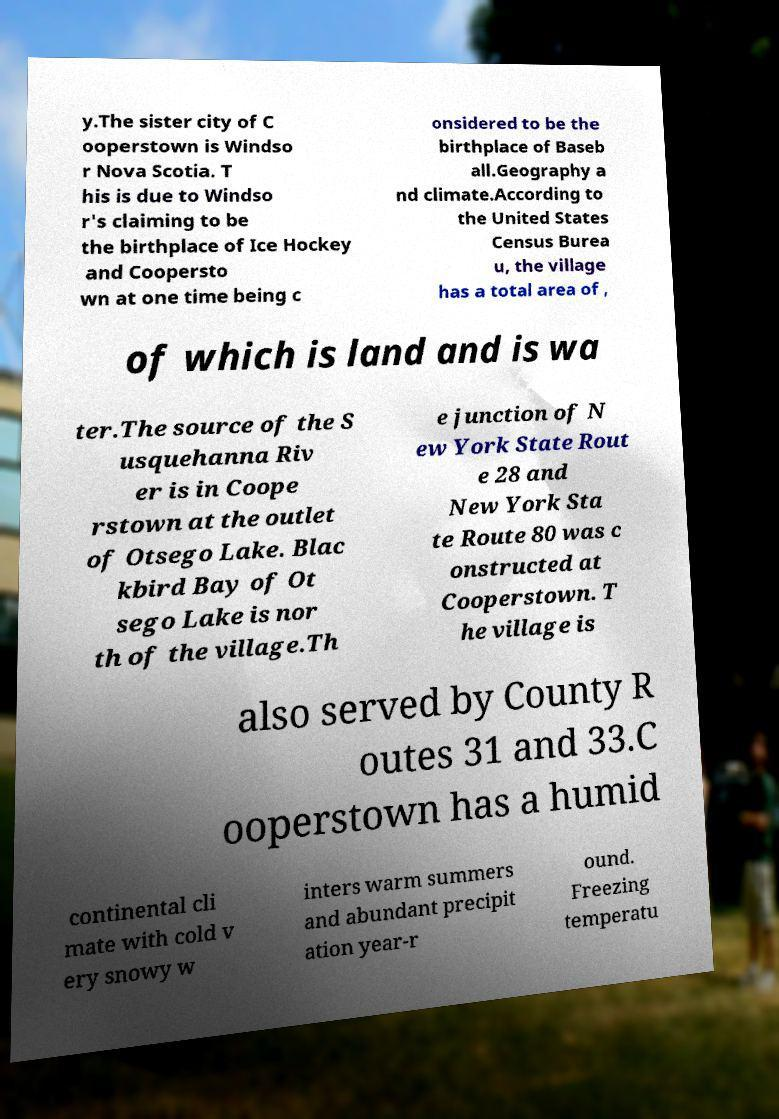For documentation purposes, I need the text within this image transcribed. Could you provide that? y.The sister city of C ooperstown is Windso r Nova Scotia. T his is due to Windso r's claiming to be the birthplace of Ice Hockey and Coopersto wn at one time being c onsidered to be the birthplace of Baseb all.Geography a nd climate.According to the United States Census Burea u, the village has a total area of , of which is land and is wa ter.The source of the S usquehanna Riv er is in Coope rstown at the outlet of Otsego Lake. Blac kbird Bay of Ot sego Lake is nor th of the village.Th e junction of N ew York State Rout e 28 and New York Sta te Route 80 was c onstructed at Cooperstown. T he village is also served by County R outes 31 and 33.C ooperstown has a humid continental cli mate with cold v ery snowy w inters warm summers and abundant precipit ation year-r ound. Freezing temperatu 